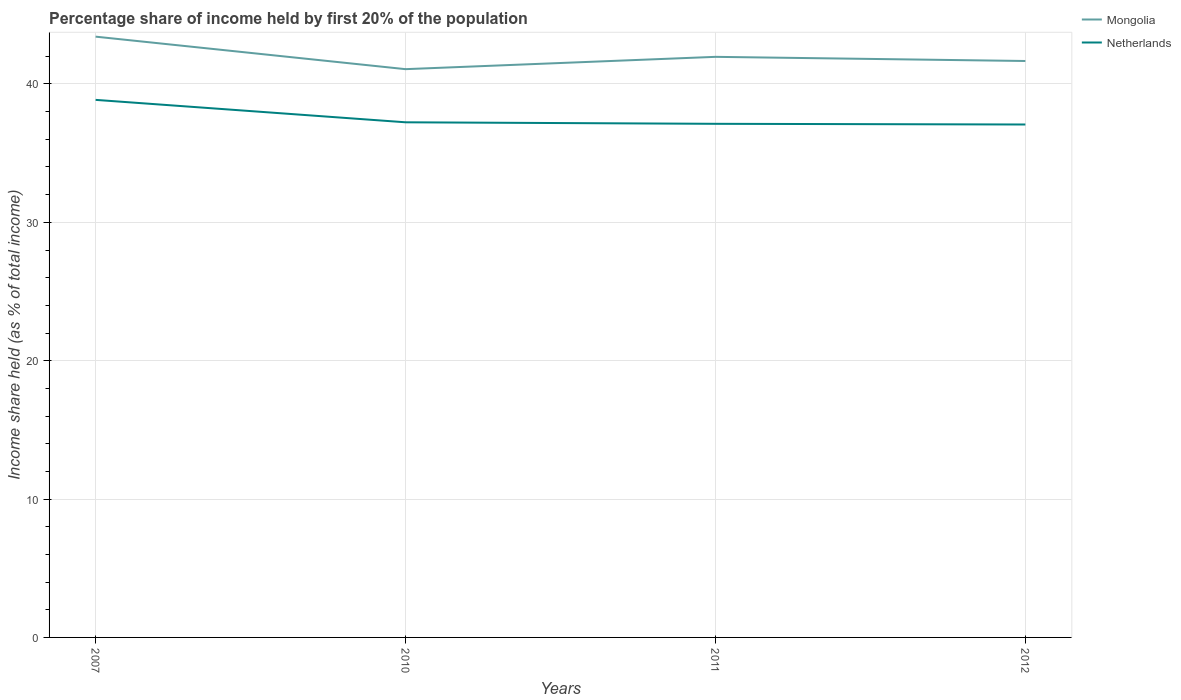Does the line corresponding to Netherlands intersect with the line corresponding to Mongolia?
Your response must be concise. No. Across all years, what is the maximum share of income held by first 20% of the population in Mongolia?
Ensure brevity in your answer.  41.07. In which year was the share of income held by first 20% of the population in Netherlands maximum?
Provide a short and direct response. 2012. What is the total share of income held by first 20% of the population in Mongolia in the graph?
Your response must be concise. -0.59. What is the difference between the highest and the second highest share of income held by first 20% of the population in Mongolia?
Your answer should be very brief. 2.35. What is the difference between the highest and the lowest share of income held by first 20% of the population in Netherlands?
Provide a succinct answer. 1. How many lines are there?
Offer a terse response. 2. How many years are there in the graph?
Offer a terse response. 4. What is the difference between two consecutive major ticks on the Y-axis?
Provide a short and direct response. 10. Are the values on the major ticks of Y-axis written in scientific E-notation?
Keep it short and to the point. No. Does the graph contain any zero values?
Make the answer very short. No. Does the graph contain grids?
Your answer should be very brief. Yes. How are the legend labels stacked?
Your answer should be very brief. Vertical. What is the title of the graph?
Ensure brevity in your answer.  Percentage share of income held by first 20% of the population. Does "Macao" appear as one of the legend labels in the graph?
Make the answer very short. No. What is the label or title of the X-axis?
Your answer should be compact. Years. What is the label or title of the Y-axis?
Your answer should be very brief. Income share held (as % of total income). What is the Income share held (as % of total income) in Mongolia in 2007?
Provide a succinct answer. 43.42. What is the Income share held (as % of total income) of Netherlands in 2007?
Keep it short and to the point. 38.85. What is the Income share held (as % of total income) of Mongolia in 2010?
Your answer should be compact. 41.07. What is the Income share held (as % of total income) of Netherlands in 2010?
Your answer should be very brief. 37.23. What is the Income share held (as % of total income) in Mongolia in 2011?
Your answer should be compact. 41.96. What is the Income share held (as % of total income) in Netherlands in 2011?
Offer a terse response. 37.12. What is the Income share held (as % of total income) of Mongolia in 2012?
Your response must be concise. 41.66. What is the Income share held (as % of total income) of Netherlands in 2012?
Offer a very short reply. 37.07. Across all years, what is the maximum Income share held (as % of total income) in Mongolia?
Provide a short and direct response. 43.42. Across all years, what is the maximum Income share held (as % of total income) of Netherlands?
Ensure brevity in your answer.  38.85. Across all years, what is the minimum Income share held (as % of total income) in Mongolia?
Offer a terse response. 41.07. Across all years, what is the minimum Income share held (as % of total income) in Netherlands?
Your answer should be compact. 37.07. What is the total Income share held (as % of total income) in Mongolia in the graph?
Give a very brief answer. 168.11. What is the total Income share held (as % of total income) in Netherlands in the graph?
Provide a short and direct response. 150.27. What is the difference between the Income share held (as % of total income) of Mongolia in 2007 and that in 2010?
Offer a very short reply. 2.35. What is the difference between the Income share held (as % of total income) of Netherlands in 2007 and that in 2010?
Keep it short and to the point. 1.62. What is the difference between the Income share held (as % of total income) of Mongolia in 2007 and that in 2011?
Your answer should be very brief. 1.46. What is the difference between the Income share held (as % of total income) of Netherlands in 2007 and that in 2011?
Offer a terse response. 1.73. What is the difference between the Income share held (as % of total income) in Mongolia in 2007 and that in 2012?
Offer a very short reply. 1.76. What is the difference between the Income share held (as % of total income) of Netherlands in 2007 and that in 2012?
Provide a succinct answer. 1.78. What is the difference between the Income share held (as % of total income) in Mongolia in 2010 and that in 2011?
Your response must be concise. -0.89. What is the difference between the Income share held (as % of total income) of Netherlands in 2010 and that in 2011?
Ensure brevity in your answer.  0.11. What is the difference between the Income share held (as % of total income) in Mongolia in 2010 and that in 2012?
Keep it short and to the point. -0.59. What is the difference between the Income share held (as % of total income) in Netherlands in 2010 and that in 2012?
Provide a short and direct response. 0.16. What is the difference between the Income share held (as % of total income) of Mongolia in 2007 and the Income share held (as % of total income) of Netherlands in 2010?
Ensure brevity in your answer.  6.19. What is the difference between the Income share held (as % of total income) in Mongolia in 2007 and the Income share held (as % of total income) in Netherlands in 2011?
Make the answer very short. 6.3. What is the difference between the Income share held (as % of total income) of Mongolia in 2007 and the Income share held (as % of total income) of Netherlands in 2012?
Provide a short and direct response. 6.35. What is the difference between the Income share held (as % of total income) of Mongolia in 2010 and the Income share held (as % of total income) of Netherlands in 2011?
Keep it short and to the point. 3.95. What is the difference between the Income share held (as % of total income) in Mongolia in 2011 and the Income share held (as % of total income) in Netherlands in 2012?
Offer a very short reply. 4.89. What is the average Income share held (as % of total income) in Mongolia per year?
Your response must be concise. 42.03. What is the average Income share held (as % of total income) in Netherlands per year?
Ensure brevity in your answer.  37.57. In the year 2007, what is the difference between the Income share held (as % of total income) of Mongolia and Income share held (as % of total income) of Netherlands?
Your response must be concise. 4.57. In the year 2010, what is the difference between the Income share held (as % of total income) in Mongolia and Income share held (as % of total income) in Netherlands?
Your response must be concise. 3.84. In the year 2011, what is the difference between the Income share held (as % of total income) in Mongolia and Income share held (as % of total income) in Netherlands?
Your answer should be very brief. 4.84. In the year 2012, what is the difference between the Income share held (as % of total income) of Mongolia and Income share held (as % of total income) of Netherlands?
Provide a succinct answer. 4.59. What is the ratio of the Income share held (as % of total income) of Mongolia in 2007 to that in 2010?
Make the answer very short. 1.06. What is the ratio of the Income share held (as % of total income) in Netherlands in 2007 to that in 2010?
Make the answer very short. 1.04. What is the ratio of the Income share held (as % of total income) of Mongolia in 2007 to that in 2011?
Offer a very short reply. 1.03. What is the ratio of the Income share held (as % of total income) of Netherlands in 2007 to that in 2011?
Give a very brief answer. 1.05. What is the ratio of the Income share held (as % of total income) of Mongolia in 2007 to that in 2012?
Offer a very short reply. 1.04. What is the ratio of the Income share held (as % of total income) of Netherlands in 2007 to that in 2012?
Your answer should be very brief. 1.05. What is the ratio of the Income share held (as % of total income) in Mongolia in 2010 to that in 2011?
Provide a short and direct response. 0.98. What is the ratio of the Income share held (as % of total income) of Netherlands in 2010 to that in 2011?
Provide a short and direct response. 1. What is the ratio of the Income share held (as % of total income) in Mongolia in 2010 to that in 2012?
Provide a succinct answer. 0.99. What is the ratio of the Income share held (as % of total income) of Netherlands in 2010 to that in 2012?
Give a very brief answer. 1. What is the ratio of the Income share held (as % of total income) of Netherlands in 2011 to that in 2012?
Ensure brevity in your answer.  1. What is the difference between the highest and the second highest Income share held (as % of total income) of Mongolia?
Your answer should be compact. 1.46. What is the difference between the highest and the second highest Income share held (as % of total income) of Netherlands?
Provide a succinct answer. 1.62. What is the difference between the highest and the lowest Income share held (as % of total income) of Mongolia?
Provide a short and direct response. 2.35. What is the difference between the highest and the lowest Income share held (as % of total income) in Netherlands?
Your answer should be compact. 1.78. 